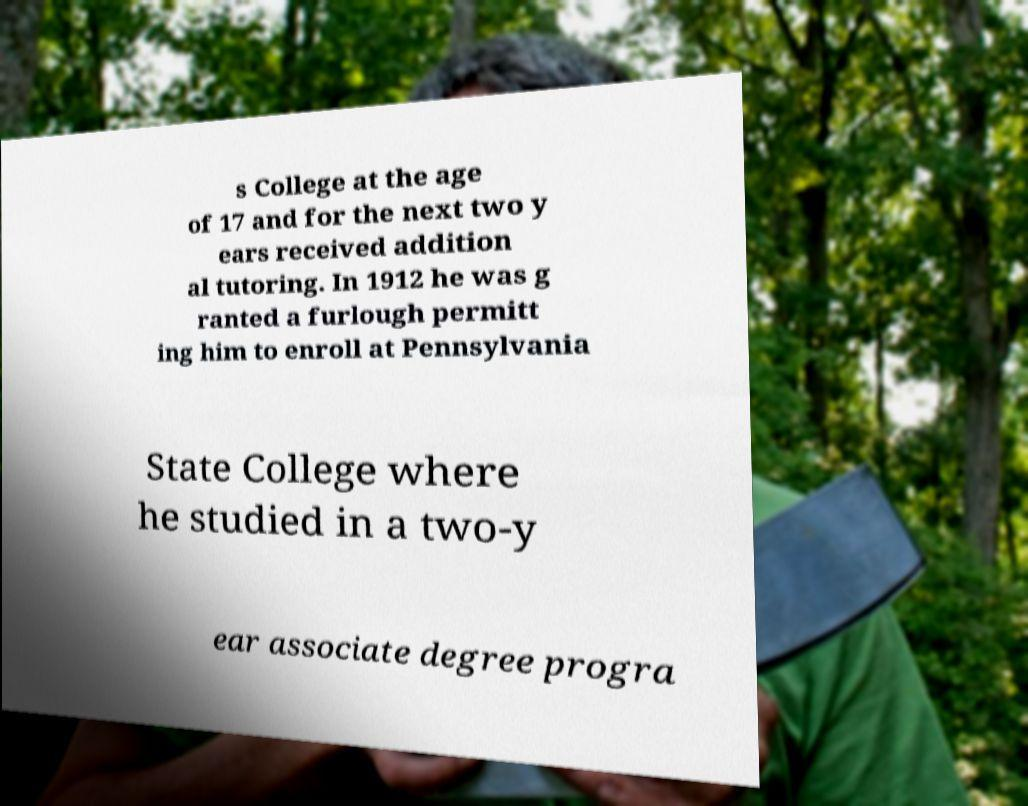There's text embedded in this image that I need extracted. Can you transcribe it verbatim? s College at the age of 17 and for the next two y ears received addition al tutoring. In 1912 he was g ranted a furlough permitt ing him to enroll at Pennsylvania State College where he studied in a two-y ear associate degree progra 